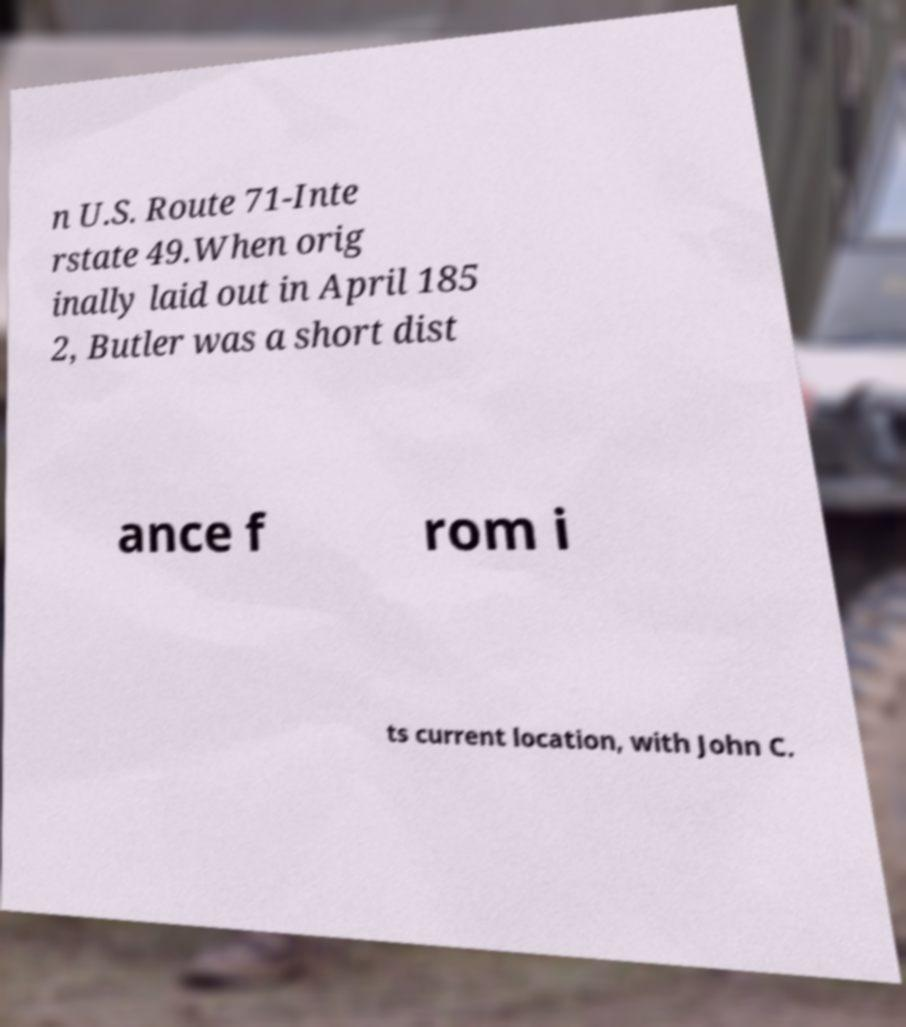Could you assist in decoding the text presented in this image and type it out clearly? n U.S. Route 71-Inte rstate 49.When orig inally laid out in April 185 2, Butler was a short dist ance f rom i ts current location, with John C. 